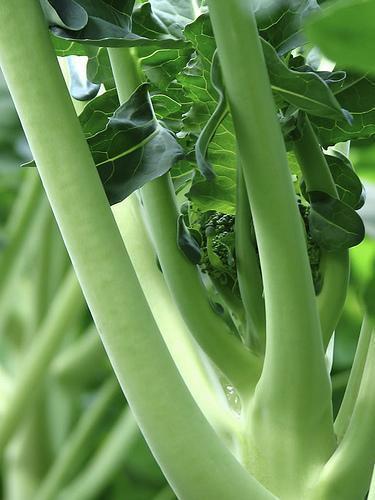How many broccolis are there?
Give a very brief answer. 2. 